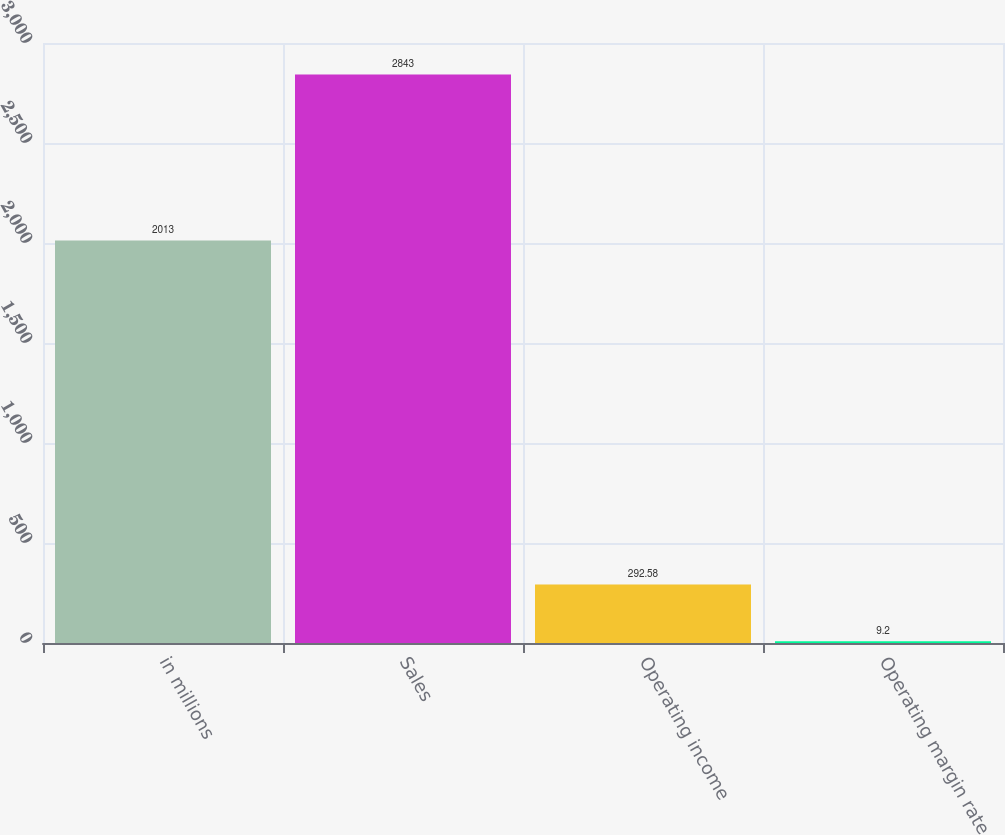<chart> <loc_0><loc_0><loc_500><loc_500><bar_chart><fcel>in millions<fcel>Sales<fcel>Operating income<fcel>Operating margin rate<nl><fcel>2013<fcel>2843<fcel>292.58<fcel>9.2<nl></chart> 